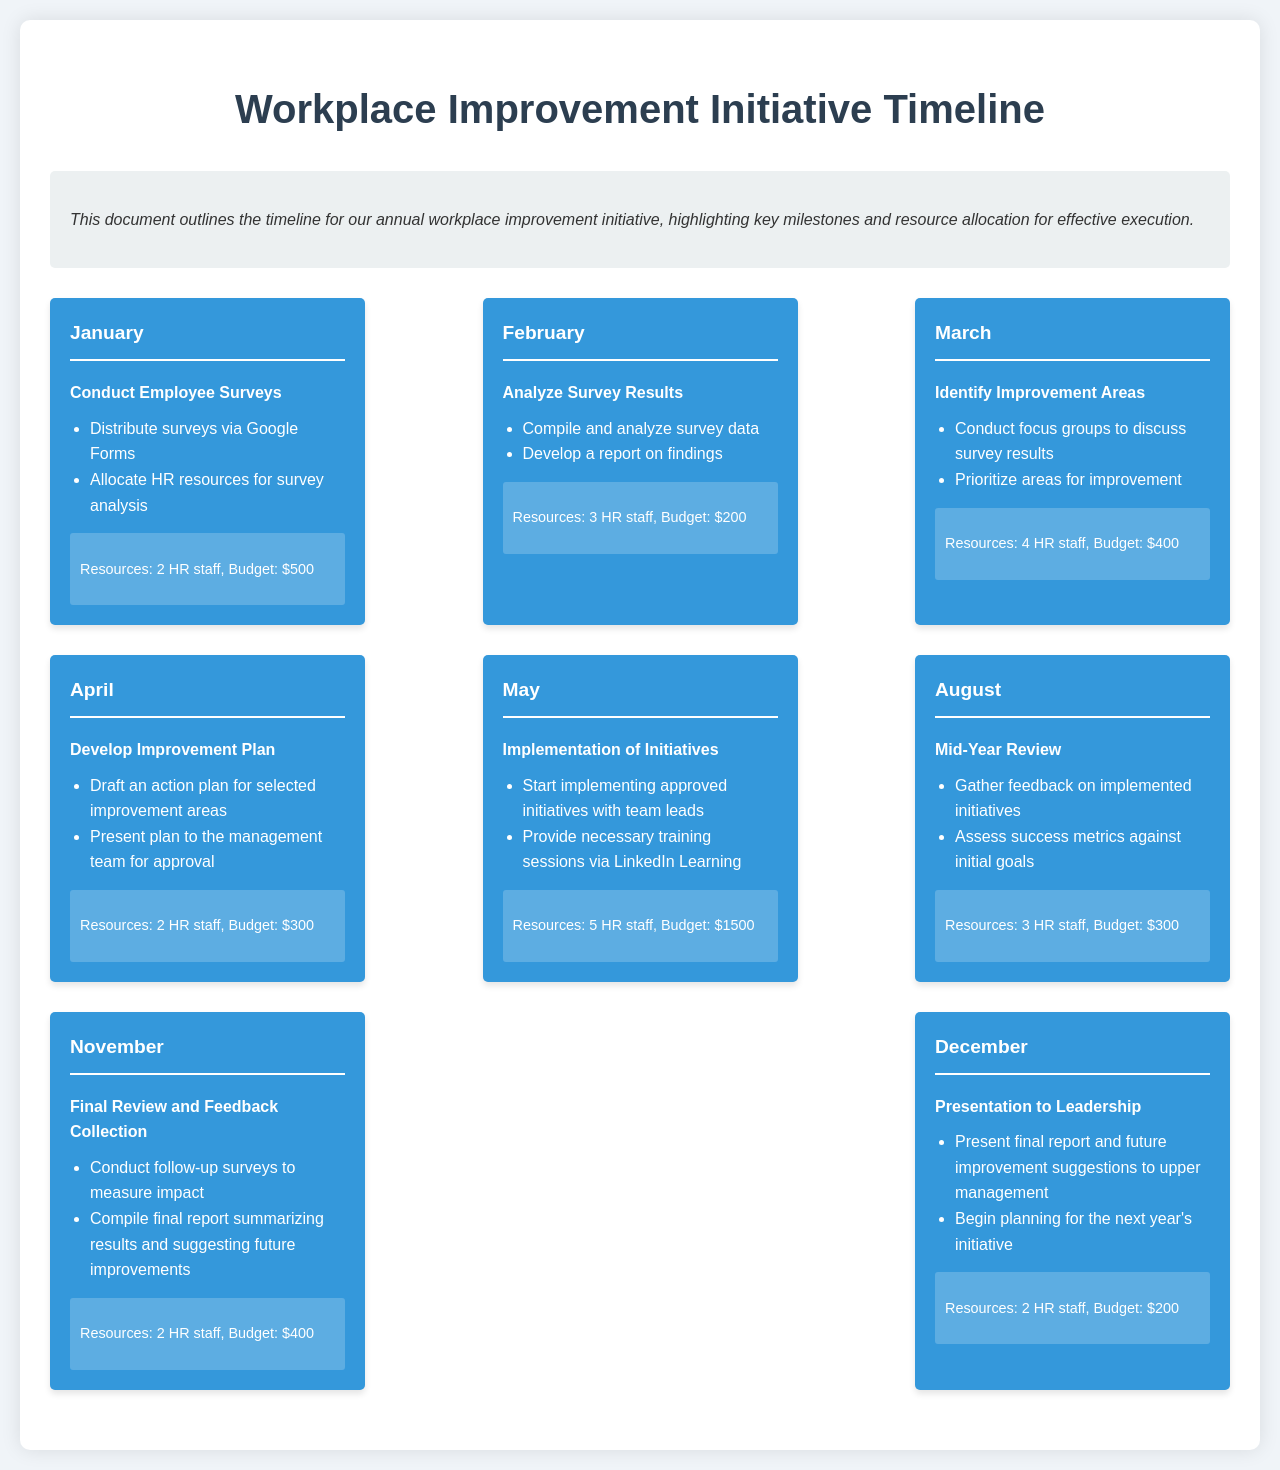What month begins the workplace improvement initiative? The initiative starts in January according to the timeline.
Answer: January How many HR staff are allocated for the implementation of initiatives in May? In May, there are 5 HR staff allocated for the implementation phase.
Answer: 5 HR staff What is the budget allocated for the mid-year review in August? The budget allocated for the mid-year review in August is $300.
Answer: $300 Which month involves conducting follow-up surveys? Follow-up surveys are conducted in November as indicated in the timeline.
Answer: November What is the key focus of the April milestone? The key focus of the April milestone is to develop an improvement plan.
Answer: Develop Improvement Plan Which month has the highest budget allocation? May has the highest budget allocation of $1500 for the implementation of initiatives.
Answer: $1500 How many HR staff are involved in the analysis of survey results in February? In February, 3 HR staff are involved in analyzing survey results.
Answer: 3 HR staff What activity occurs in December related to leadership? In December, a presentation to leadership takes place summarizing the final report and future suggestions.
Answer: Presentation to Leadership In which month is the survey distributed? The survey is distributed in January as the first milestone in the timeline.
Answer: January 